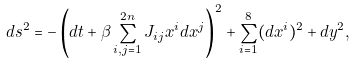Convert formula to latex. <formula><loc_0><loc_0><loc_500><loc_500>d s ^ { 2 } = - \left ( d t + \beta \sum _ { i , j = 1 } ^ { 2 n } J _ { i j } x ^ { i } d x ^ { j } \right ) ^ { 2 } + \sum _ { i = 1 } ^ { 8 } ( d x ^ { i } ) ^ { 2 } + d y ^ { 2 } ,</formula> 